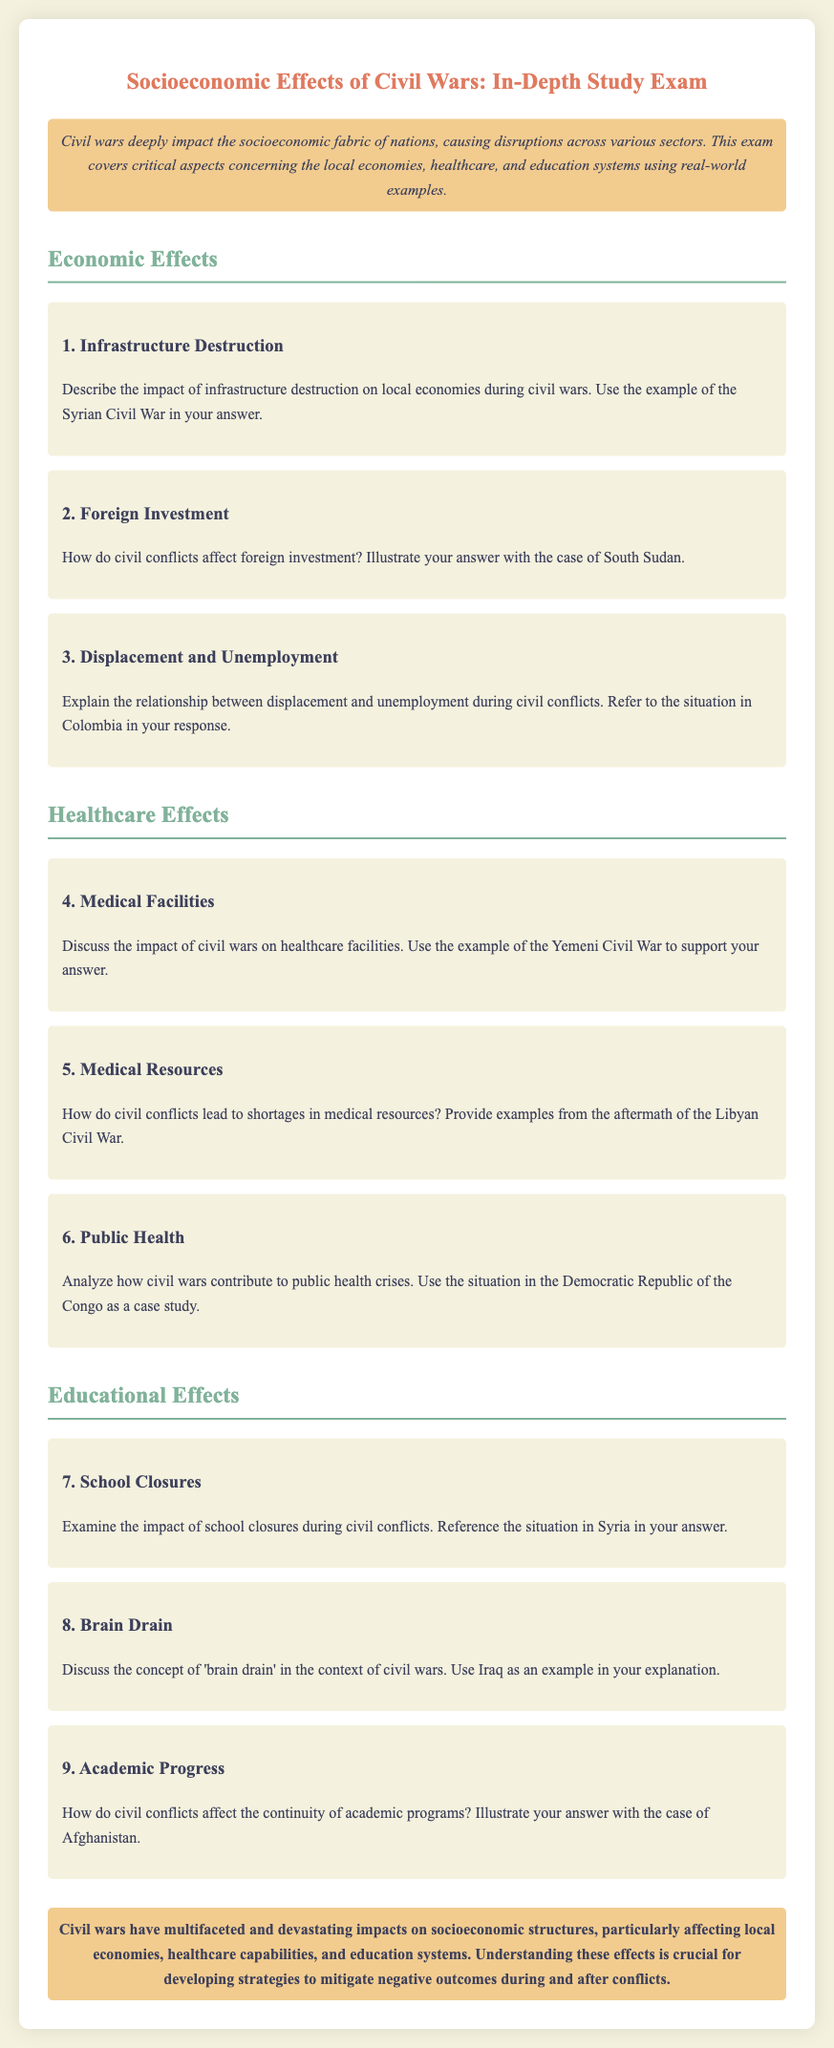What is the title of the exam? The title of the exam is presented at the top of the document as "Socioeconomic Effects of Civil Wars: In-Depth Study Exam."
Answer: Socioeconomic Effects of Civil Wars: In-Depth Study Exam What is the primary focus of the exam? The primary focus of the exam is described in the introduction and it covers socioeconomic impacts including local economies, healthcare, and education systems.
Answer: Socioeconomic impacts Who is the case study for the impact of infrastructure destruction? The case study for the impact of infrastructure destruction is mentioned in the document specifically as the Syrian Civil War.
Answer: Syrian Civil War Which civil war is referenced for public health crises? The civil war referenced for public health crises is the Democratic Republic of the Congo case study.
Answer: Democratic Republic of the Congo What is the color of the section headings in the document? The color of the section headings is described in the styling and is a shade of green, specifically #81b29a.
Answer: #81b29a What example is used to illustrate 'brain drain'? The document specifically mentions Iraq as the example used to illustrate 'brain drain.'
Answer: Iraq 